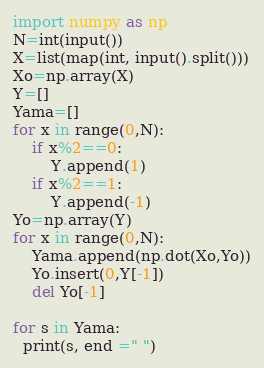<code> <loc_0><loc_0><loc_500><loc_500><_Python_>import numpy as np
N=int(input())
X=list(map(int, input().split()))
Xo=np.array(X)
Y=[]
Yama=[]
for x in range(0,N):
    if x%2==0:
        Y.append(1)
    if x%2==1:
        Y.append(-1)
Yo=np.array(Y)
for x in range(0,N):
    Yama.append(np.dot(Xo,Yo))
    Yo.insert(0,Y[-1])
    del Yo[-1]

for s in Yama:
  print(s, end =" ")
</code> 